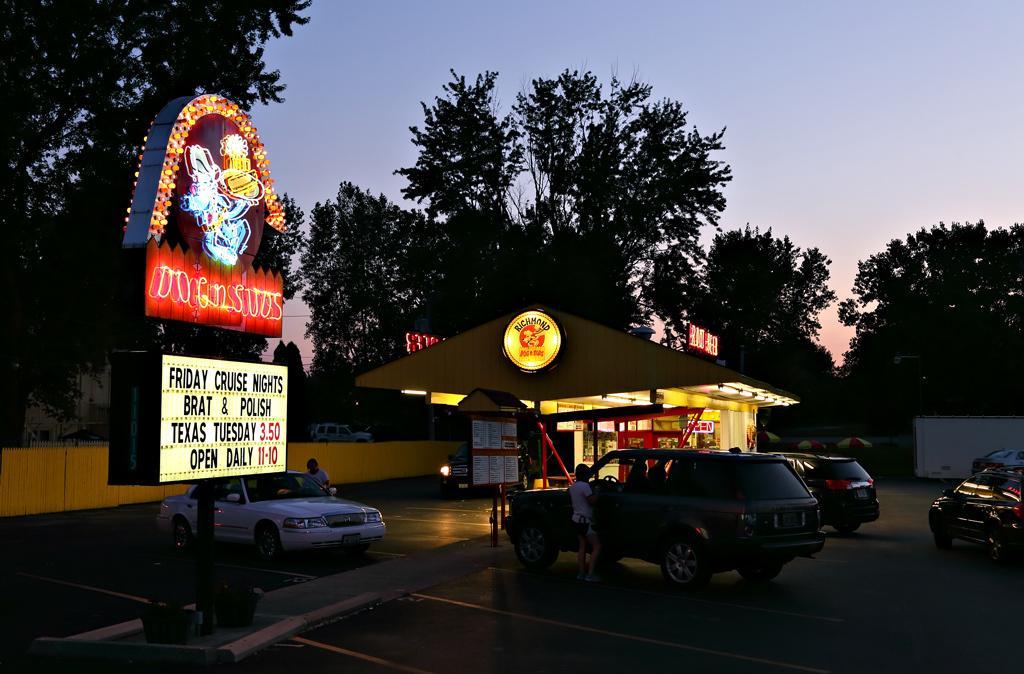In one or two sentences, can you explain what this image depicts? There are some vehicles and some persons standing at the bottom of this image, and there is a shelter in the middle of this image and there is an advertising board on the left side of this image. There is a wall in the background. There are some trees as we can see in the middle of this image, and there is a sky at the top of this image. 